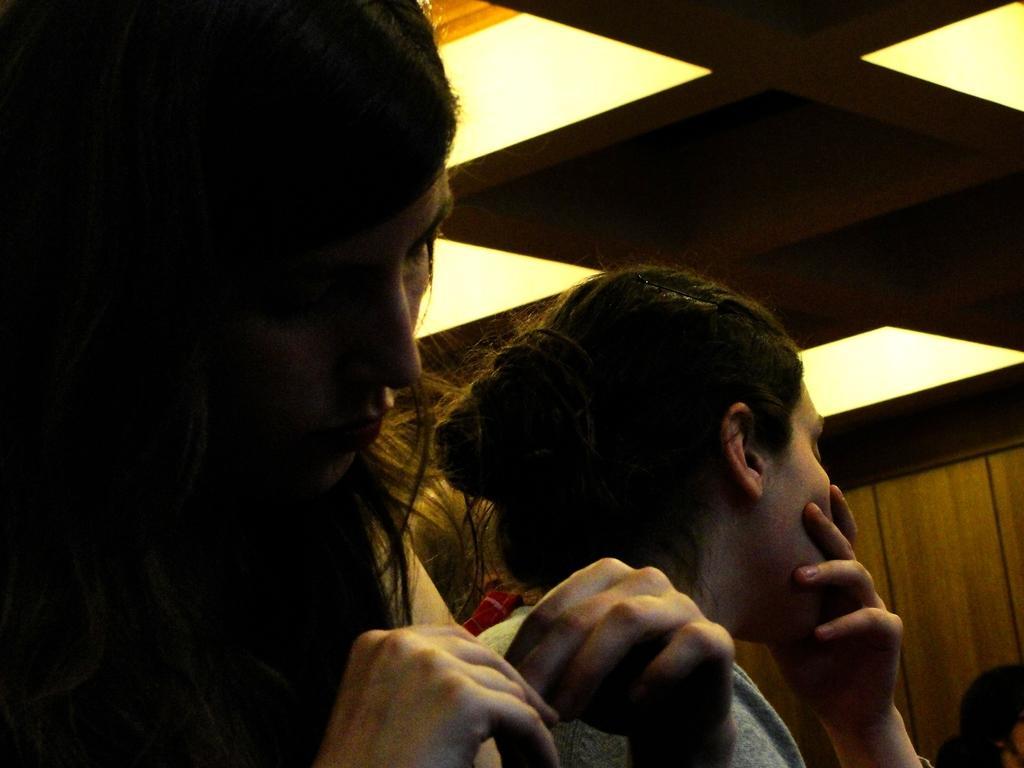Please provide a concise description of this image. In this picture I can see couple of them standing and I can see lights on the ceiling. 